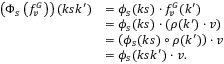Convert formula to latex. <formula><loc_0><loc_0><loc_500><loc_500>\begin{array} { r l } { \left ( \Phi _ { s } \left ( f _ { v } ^ { G } \right ) \right ) ( k s k ^ { \prime } ) } & { = \phi _ { s } ( k s ) \cdot f _ { v } ^ { G } ( k ^ { \prime } ) } \\ & { = \phi _ { s } ( k s ) \cdot \left ( \rho ( k ^ { \prime } ) \cdot v \right ) } \\ & { = \left ( \phi _ { s } ( k s ) \circ \rho ( k ^ { \prime } ) \right ) \cdot v } \\ & { = \phi _ { s } ( k s k ^ { \prime } ) \cdot v . } \end{array}</formula> 